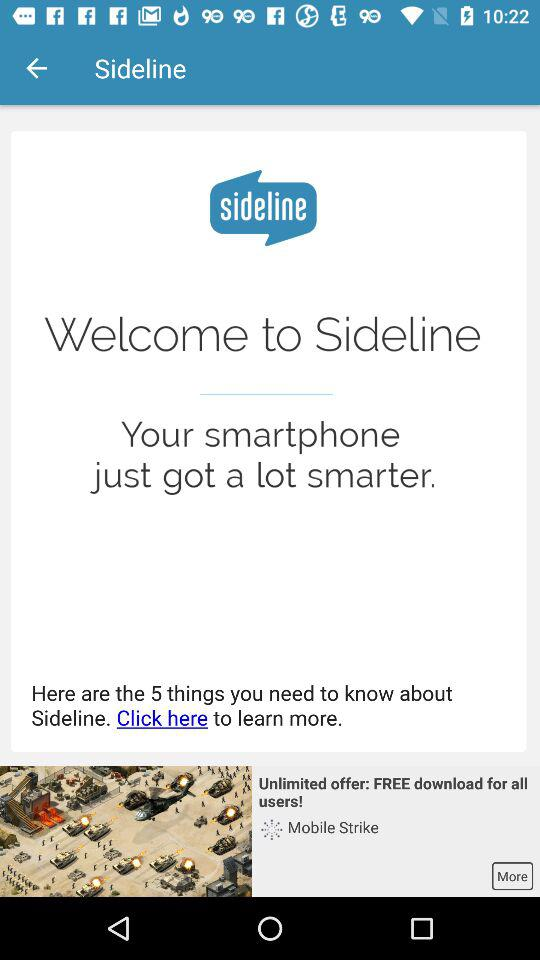How many things do we need to know about the sideline? There are 5 things you need to know about the sideline. 